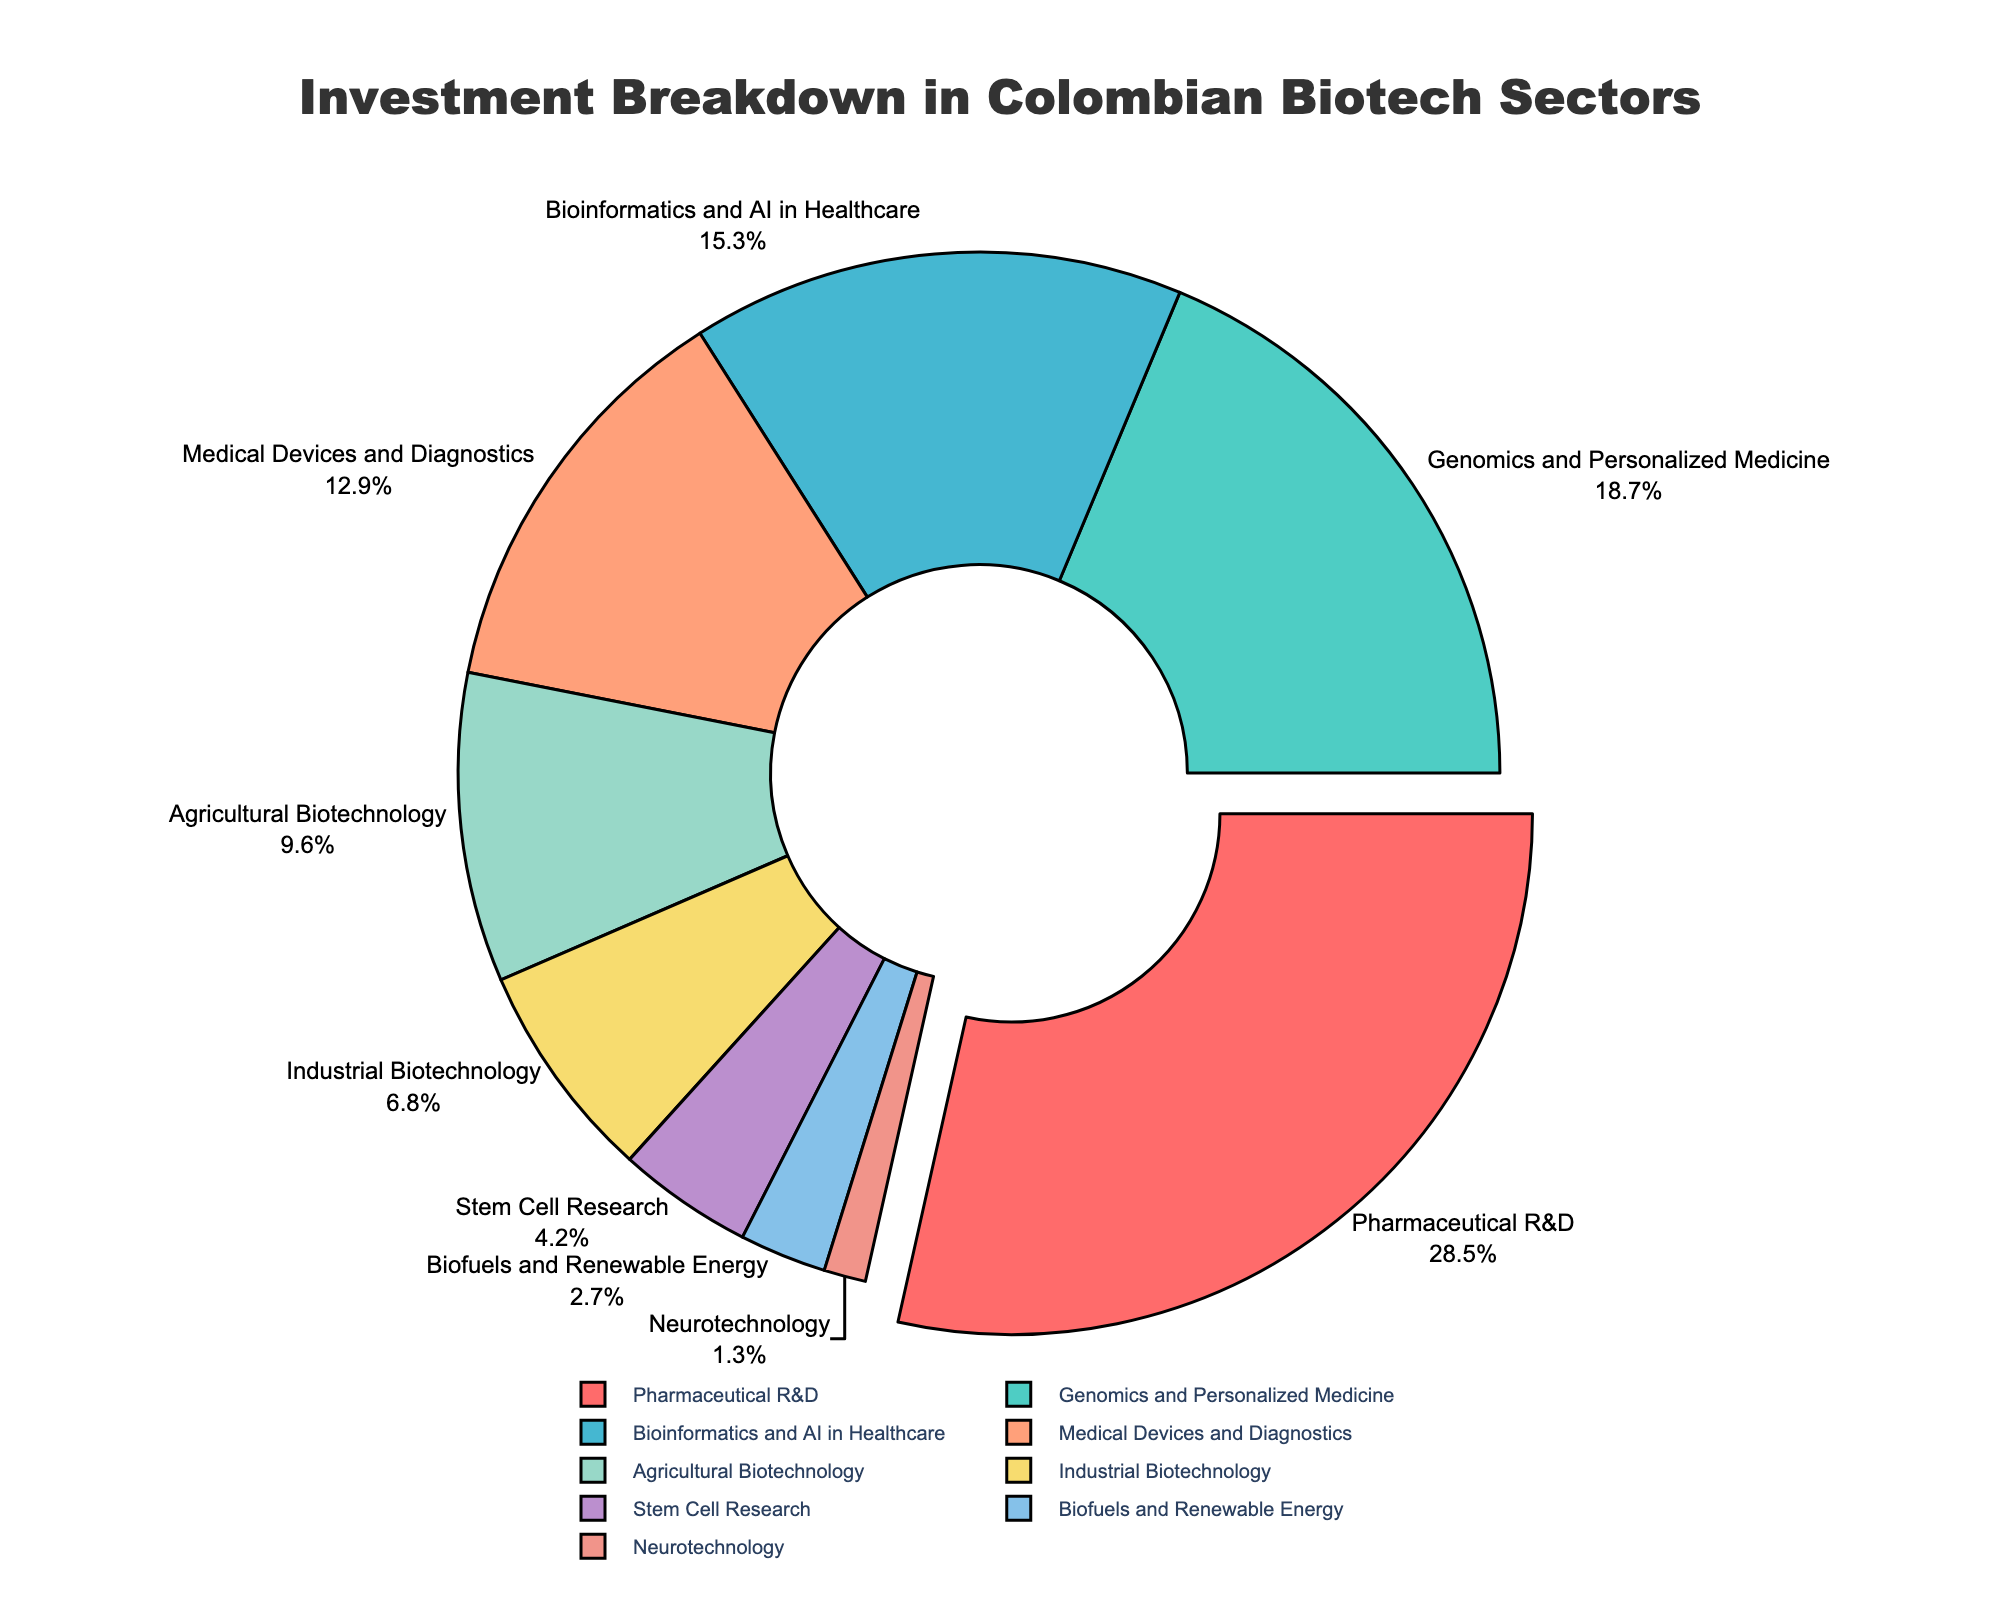How much greater is the investment percentage in Pharmaceutical R&D compared to Bioinformatics and AI in Healthcare? The investment percentage in Pharmaceutical R&D is 28.5%, and in Bioinformatics and AI in Healthcare is 15.3%. Subtracting the latter from the former gives 28.5% - 15.3% = 13.2%.
Answer: 13.2% Which sector receives the least investment? The sector with the smallest investment percentage is Neurotechnology, with 1.3% investment.
Answer: Neurotechnology What is the sum of the investment percentages of Agricultural Biotechnology and Industrial Biotechnology? The investment percentage for Agricultural Biotechnology is 9.6% and for Industrial Biotechnology is 6.8%. Adding these gives 9.6% + 6.8% = 16.4%.
Answer: 16.4% Is the investment in Medical Devices and Diagnostics greater than in Agricultural Biotechnology? Medical Devices and Diagnostics has an investment percentage of 12.9%, while Agricultural Biotechnology has 9.6%. Since 12.9% > 9.6%, the investment is indeed greater.
Answer: Yes Calculate the average investment percentage of the top three sectors. The top three sectors by investment percentage are Pharmaceutical R&D (28.5%), Genomics and Personalized Medicine (18.7%), and Bioinformatics and AI in Healthcare (15.3%). Their average is (28.5% + 18.7% + 15.3%) / 3 = 62.5% / 3 ≈ 20.83%.
Answer: 20.83% Which sector has the largest share of investment and how is it visually indicated in the figure? Pharmaceutical R&D has the largest share of investment at 28.5%, and it is visually indicated by being slightly pulled out from the pie chart.
Answer: Pharmaceutical R&D What is the combined investment percentage of sectors with more than 15% investment? The sectors with more than 15% investment are Pharmaceutical R&D (28.5%), Genomics and Personalized Medicine (18.7%), and Bioinformatics and AI in Healthcare (15.3%). Their combined investment is 28.5% + 18.7% + 15.3% = 62.5%.
Answer: 62.5% Compare the investments in Stem Cell Research and Biofuels and Renewable Energy. Which sector receives more investment and by how much? Stem Cell Research has an investment of 4.2% and Biofuels and Renewable Energy has 2.7%. Stem Cell Research receives more investment by 4.2% - 2.7% = 1.5%.
Answer: Stem Cell Research, 1.5% What percentage of the total investment is distributed among sectors other than the top three? The top three sectors are Pharmaceutical R&D (28.5%), Genomics and Personalized Medicine (18.7%), and Bioinformatics and AI in Healthcare (15.3%). Their total is 28.5% + 18.7% + 15.3% = 62.5%. The remaining investment is 100% - 62.5% = 37.5%.
Answer: 37.5% Of the sectors shown, which one has a similar investment percentage to Agricultural Biotechnology and what is that percentage? Agricultural Biotechnology has an investment of 9.6%. Medical Devices and Diagnostics has a slightly higher percentage at 12.9%, but it's relatively close.
Answer: Medical Devices and Diagnostics, 12.9% 